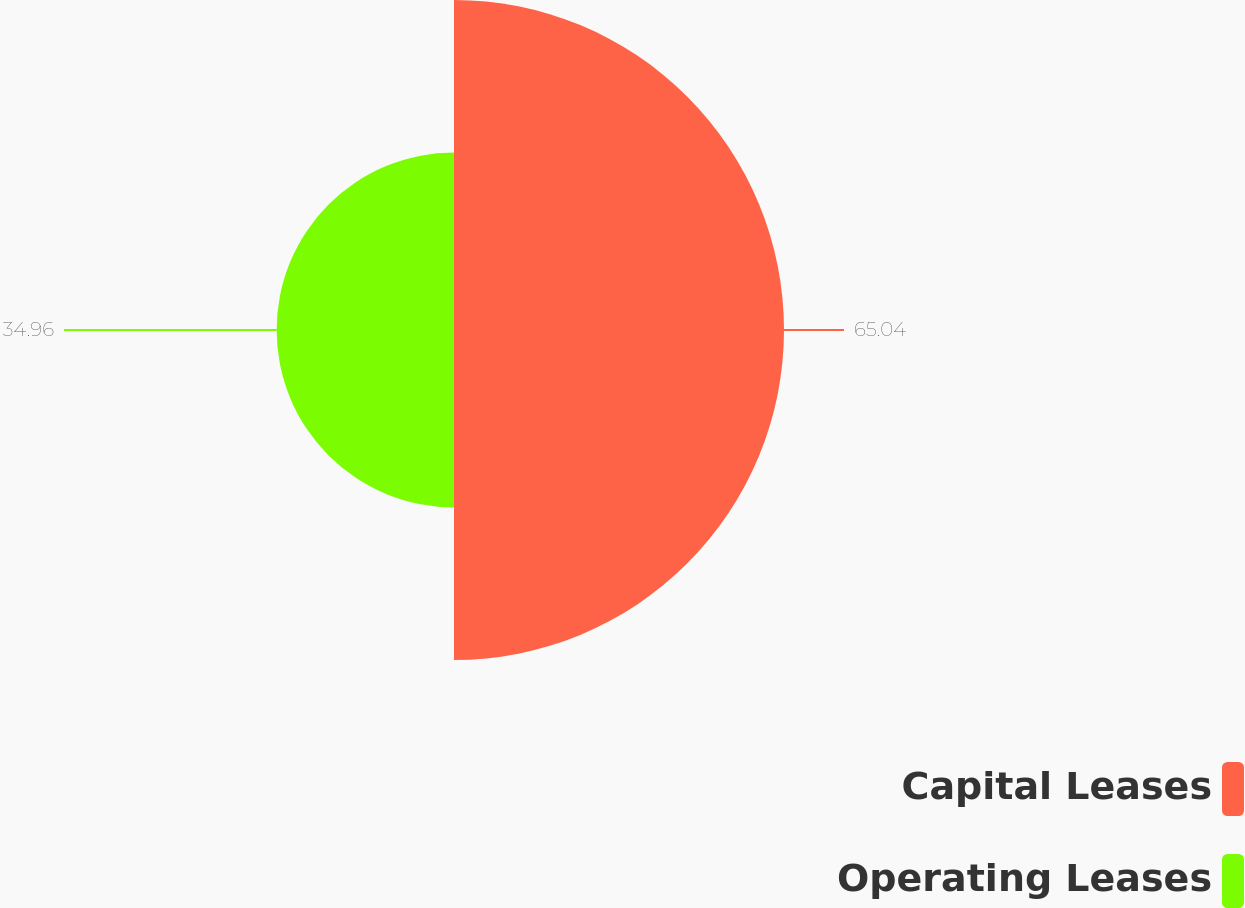<chart> <loc_0><loc_0><loc_500><loc_500><pie_chart><fcel>Capital Leases<fcel>Operating Leases<nl><fcel>65.04%<fcel>34.96%<nl></chart> 